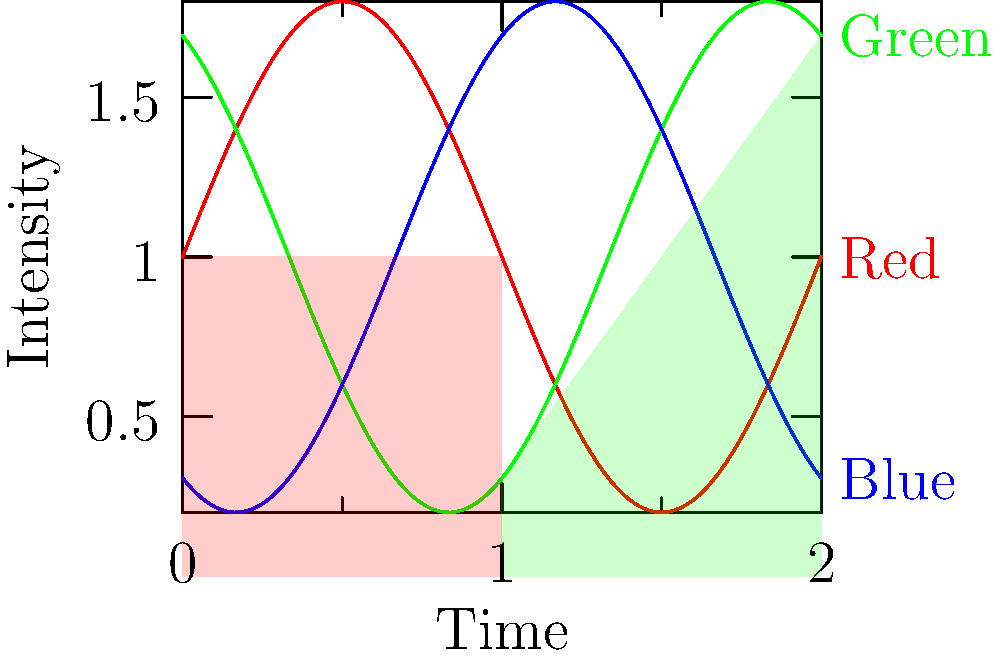In anime scene composition, color theory plays a crucial role. The graph shows the intensity of red, green, and blue colors over time in a hypothetical anime scene. Which color combination would likely create a sunset-like atmosphere in the middle of the scene (around time 1)? Let's analyze this step-by-step:

1. The graph shows the intensity of three primary colors (red, green, and blue) over time in an anime scene.

2. At time 1 (the middle of the scene):
   - Red intensity is at its peak
   - Blue intensity is at its lowest point
   - Green intensity is decreasing but still present

3. A sunset-like atmosphere typically involves:
   - High intensity of warm colors (red, orange)
   - Low intensity of cool colors (blue)
   - Some presence of transitional colors (like yellow, which is a mix of red and green)

4. The color combination at time 1 matches these criteria:
   - Red is at its highest, providing the warm tones characteristic of a sunset
   - Blue is at its lowest, which is typical for a sunset as the sky loses its daytime blue
   - Green is present but decreasing, which can mix with red to create yellow and orange hues

5. This combination of high red, low blue, and some green would likely create golden, orange, and pink hues typical of a sunset sky in an anime scene.

Therefore, the color combination at time 1 is ideal for creating a sunset-like atmosphere in the anime scene.
Answer: Red + Green (with low Blue) 